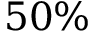Convert formula to latex. <formula><loc_0><loc_0><loc_500><loc_500>5 0 \%</formula> 